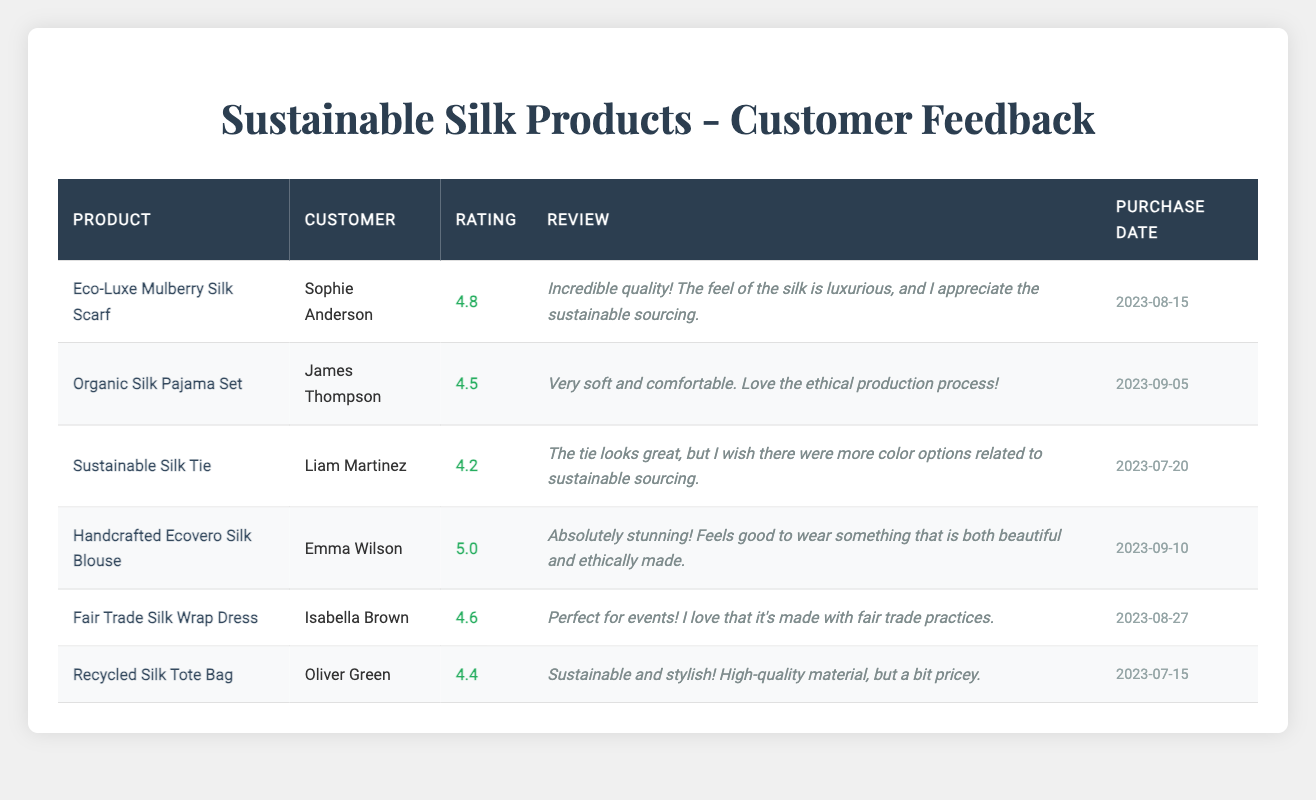What is the highest rating received for a product? The highest rating in the table is 5.0 for the Handcrafted Ecovero Silk Blouse, as evidenced by the column showing ratings for each product.
Answer: 5.0 Which product received a rating of 4.4? The product with a rating of 4.4 is the Recycled Silk Tote Bag, which is indicated in the rating column next to the product name.
Answer: Recycled Silk Tote Bag How many customers rated the Fair Trade Silk Wrap Dress? The Fair Trade Silk Wrap Dress was rated by one customer, Isabella Brown, as seen in the review section for that product.
Answer: 1 What is the average rating of eco-friendly silk products in this table? To find the average, add all the ratings: 4.8 + 4.5 + 4.2 + 5.0 + 4.6 + 4.4 = 27.5; then divide by the number of products (6). The average is 27.5 / 6 = 4.58.
Answer: 4.58 Did any customer mention the high price of their product? Yes, Oliver Green noted that the Recycled Silk Tote Bag is "high-quality material, but a bit pricey," confirming the presence of price-related feedback.
Answer: Yes What product received the lowest rating? The Sustainable Silk Tie has the lowest rating of 4.2, as identified by comparing the ratings in the table.
Answer: Sustainable Silk Tie Which customer gave the highest rating? Emma Wilson gave the highest rating of 5.0 for the Handcrafted Ecovero Silk Blouse, which can be found in the customer's name column next to the highest rating.
Answer: Emma Wilson How many products have ratings lower than 4.5? There are two products rated lower than 4.5: the Sustainable Silk Tie (4.2) and the Recycled Silk Tote Bag (4.4), counted by filtering the ratings in the table.
Answer: 2 What feedback did Liam Martinez provide about the Sustainable Silk Tie? Liam Martinez's feedback indicated that the tie looks great, but he wished for more color options related to sustainable sourcing, which is summarized in the review column for that product.
Answer: The tie looks great; wished for more color options 